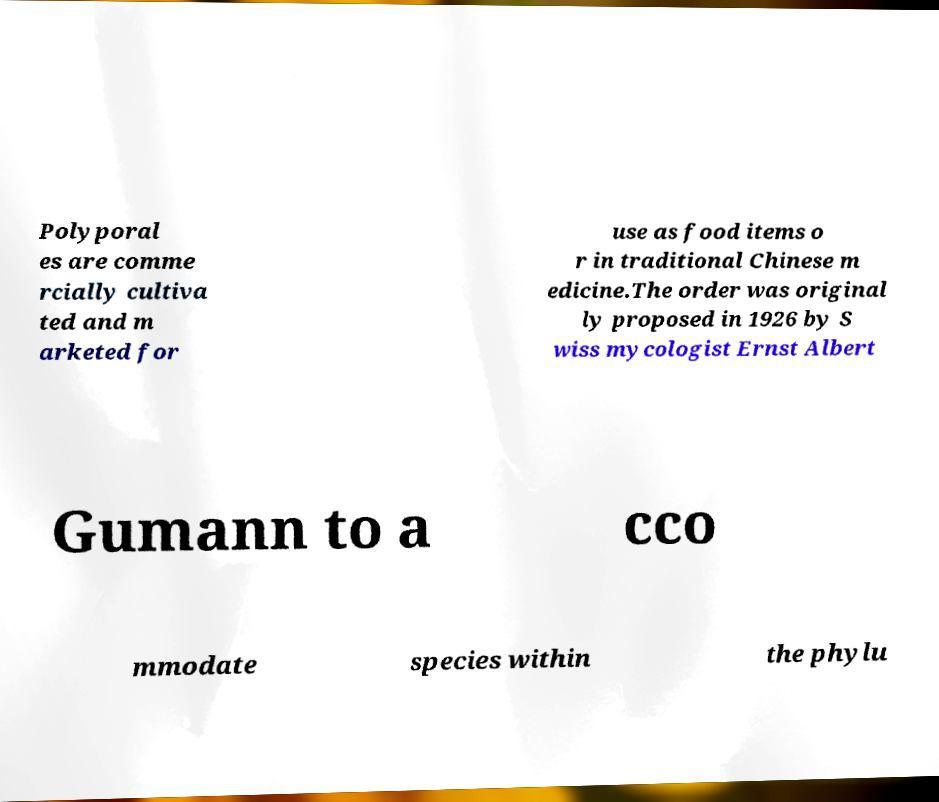I need the written content from this picture converted into text. Can you do that? Polyporal es are comme rcially cultiva ted and m arketed for use as food items o r in traditional Chinese m edicine.The order was original ly proposed in 1926 by S wiss mycologist Ernst Albert Gumann to a cco mmodate species within the phylu 